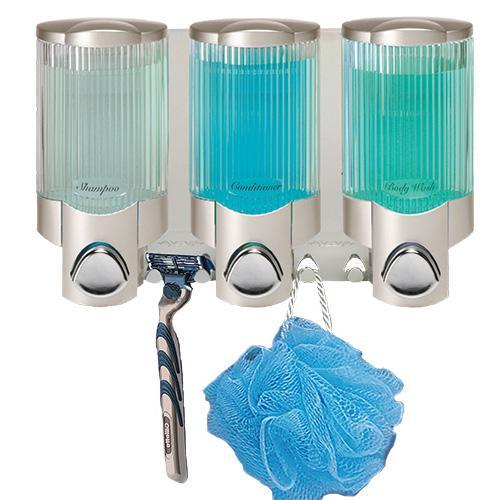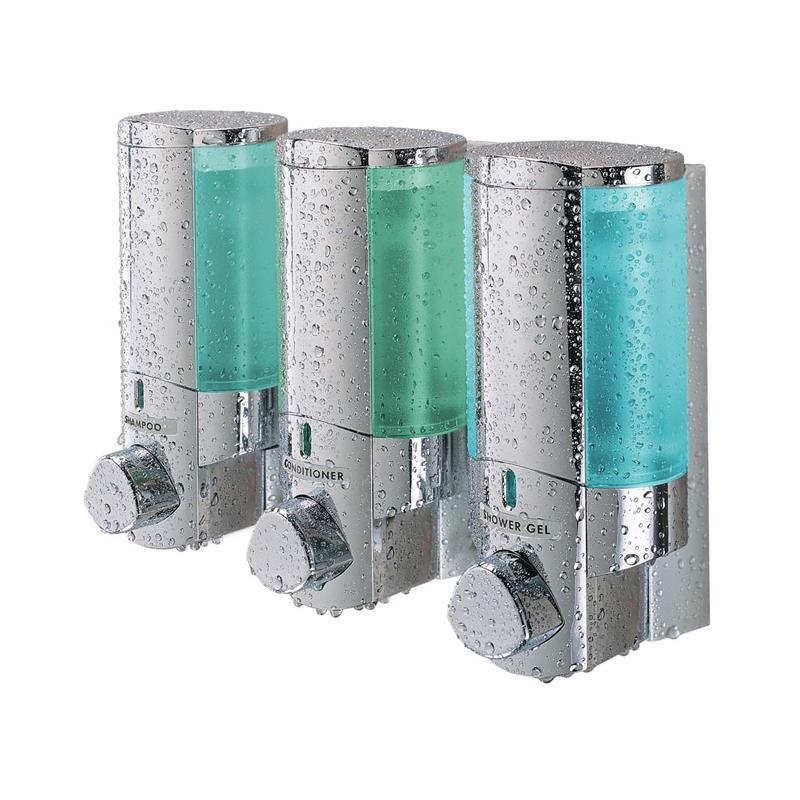The first image is the image on the left, the second image is the image on the right. Considering the images on both sides, is "there is exactly one dispensing button in one of the images" valid? Answer yes or no. No. 